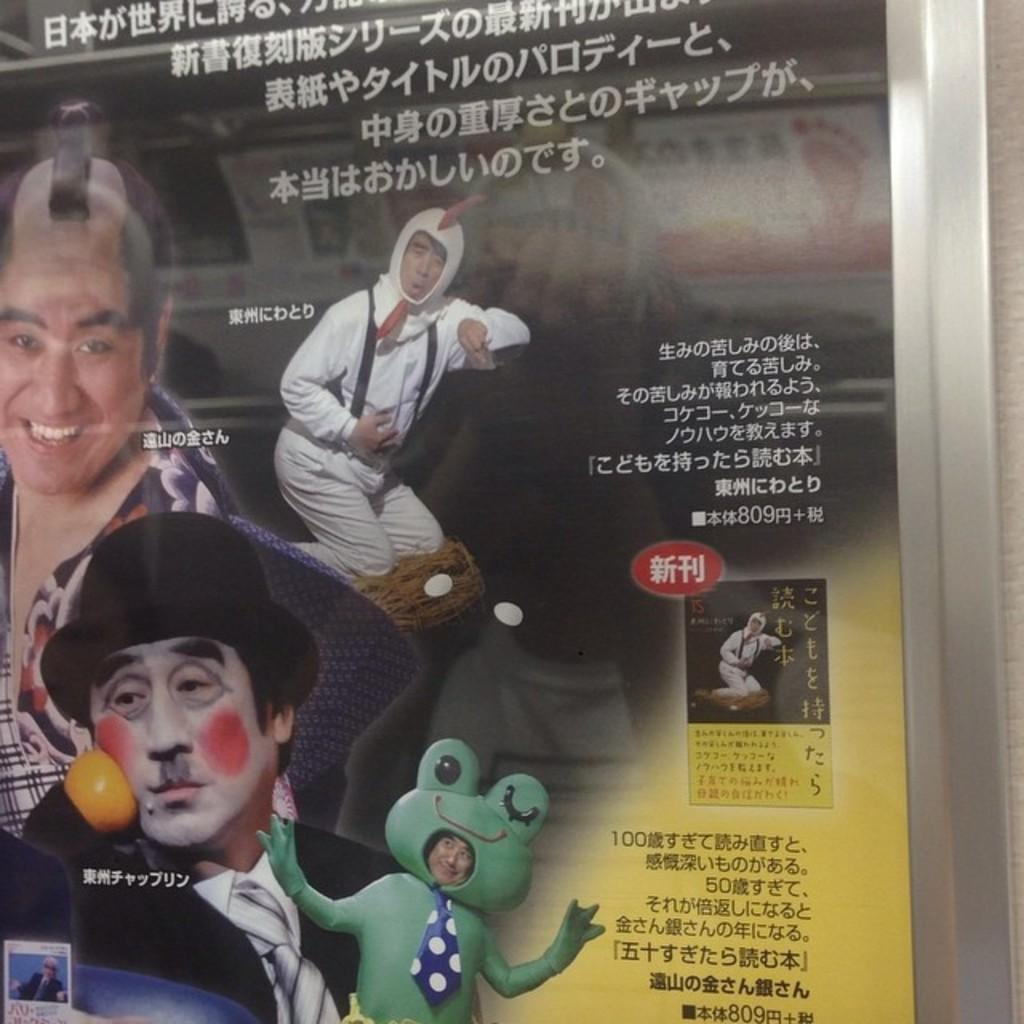What is present in the image? There is a poster in the image. What can be seen on the poster? There are people visible on the poster. What color is the crayon being used by the people on the poster? There is no crayon present in the image; it only features a poster with people on it. 